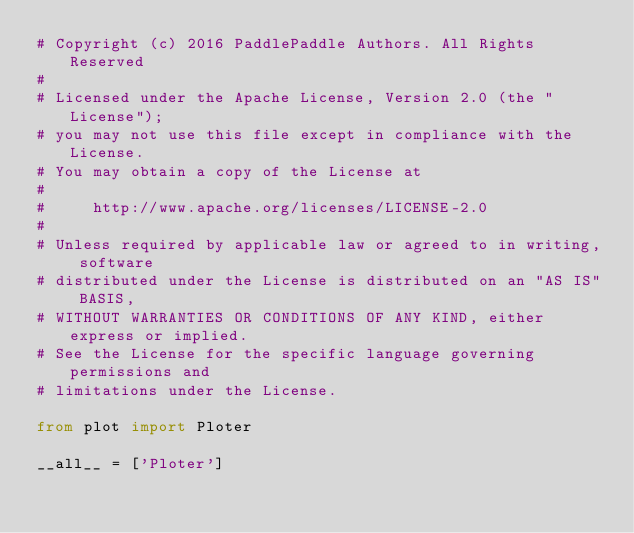<code> <loc_0><loc_0><loc_500><loc_500><_Python_># Copyright (c) 2016 PaddlePaddle Authors. All Rights Reserved
#
# Licensed under the Apache License, Version 2.0 (the "License");
# you may not use this file except in compliance with the License.
# You may obtain a copy of the License at
#
#     http://www.apache.org/licenses/LICENSE-2.0
#
# Unless required by applicable law or agreed to in writing, software
# distributed under the License is distributed on an "AS IS" BASIS,
# WITHOUT WARRANTIES OR CONDITIONS OF ANY KIND, either express or implied.
# See the License for the specific language governing permissions and
# limitations under the License.

from plot import Ploter

__all__ = ['Ploter']
</code> 